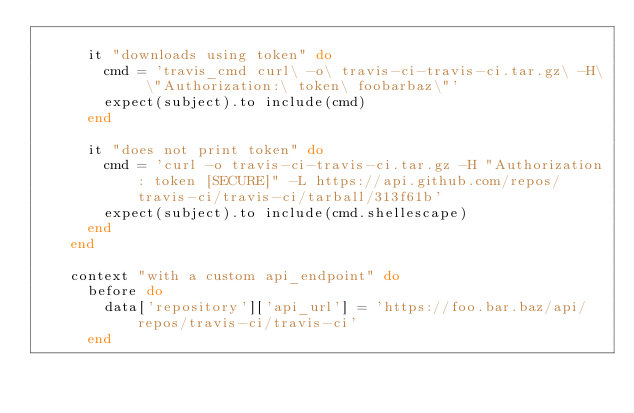Convert code to text. <code><loc_0><loc_0><loc_500><loc_500><_Ruby_>
      it "downloads using token" do
        cmd = 'travis_cmd curl\ -o\ travis-ci-travis-ci.tar.gz\ -H\ \"Authorization:\ token\ foobarbaz\"'
        expect(subject).to include(cmd)
      end

      it "does not print token" do
        cmd = 'curl -o travis-ci-travis-ci.tar.gz -H "Authorization: token [SECURE]" -L https://api.github.com/repos/travis-ci/travis-ci/tarball/313f61b'
        expect(subject).to include(cmd.shellescape)
      end
    end

    context "with a custom api_endpoint" do
      before do
        data['repository']['api_url'] = 'https://foo.bar.baz/api/repos/travis-ci/travis-ci'
      end
</code> 